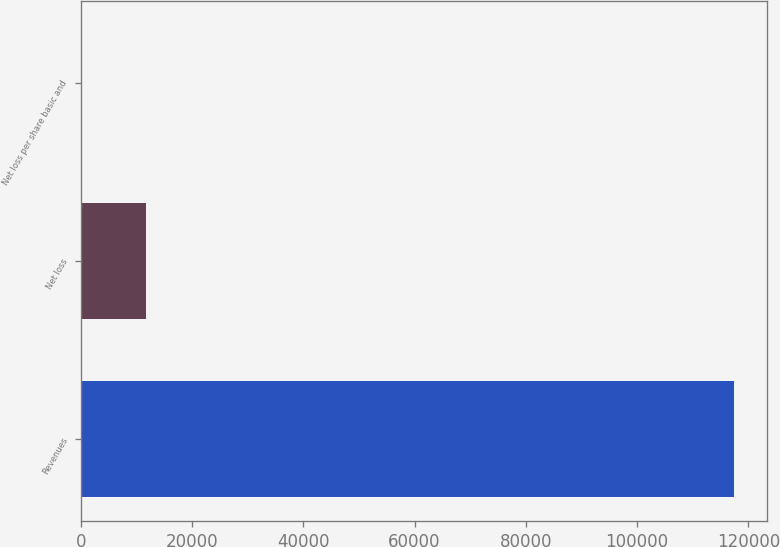Convert chart. <chart><loc_0><loc_0><loc_500><loc_500><bar_chart><fcel>Revenues<fcel>Net loss<fcel>Net loss per share basic and<nl><fcel>117455<fcel>11745.5<fcel>0.01<nl></chart> 